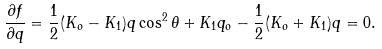Convert formula to latex. <formula><loc_0><loc_0><loc_500><loc_500>\frac { \partial f } { \partial q } = \frac { 1 } { 2 } ( K _ { o } - K _ { 1 } ) q \cos ^ { 2 } { \theta } + K _ { 1 } q _ { o } - \frac { 1 } { 2 } ( K _ { o } + K _ { 1 } ) q = 0 .</formula> 